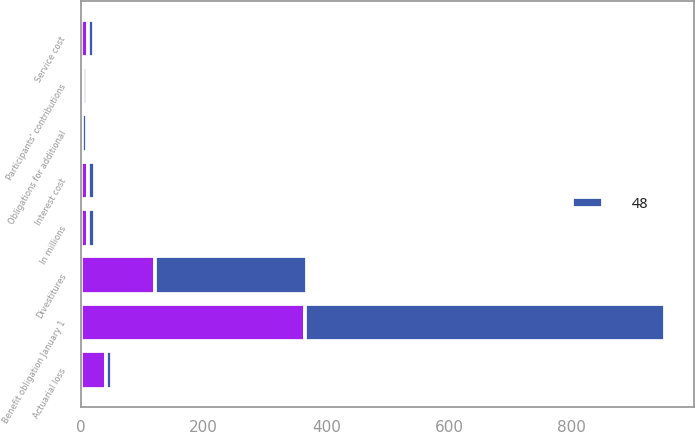Convert chart to OTSL. <chart><loc_0><loc_0><loc_500><loc_500><stacked_bar_chart><ecel><fcel>In millions<fcel>Benefit obligation January 1<fcel>Obligations for additional<fcel>Service cost<fcel>Interest cost<fcel>Participants' contributions<fcel>Divestitures<fcel>Actuarial loss<nl><fcel>nan<fcel>11<fcel>365<fcel>1<fcel>11<fcel>12<fcel>3<fcel>121<fcel>40<nl><fcel>48<fcel>11<fcel>587<fcel>9<fcel>10<fcel>11<fcel>7<fcel>247<fcel>10<nl></chart> 